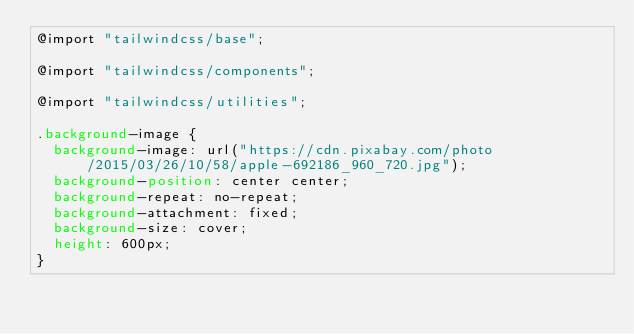Convert code to text. <code><loc_0><loc_0><loc_500><loc_500><_CSS_>@import "tailwindcss/base";

@import "tailwindcss/components";

@import "tailwindcss/utilities";

.background-image {
  background-image: url("https://cdn.pixabay.com/photo/2015/03/26/10/58/apple-692186_960_720.jpg");
  background-position: center center;
  background-repeat: no-repeat;
  background-attachment: fixed;
  background-size: cover;
  height: 600px;
}
</code> 